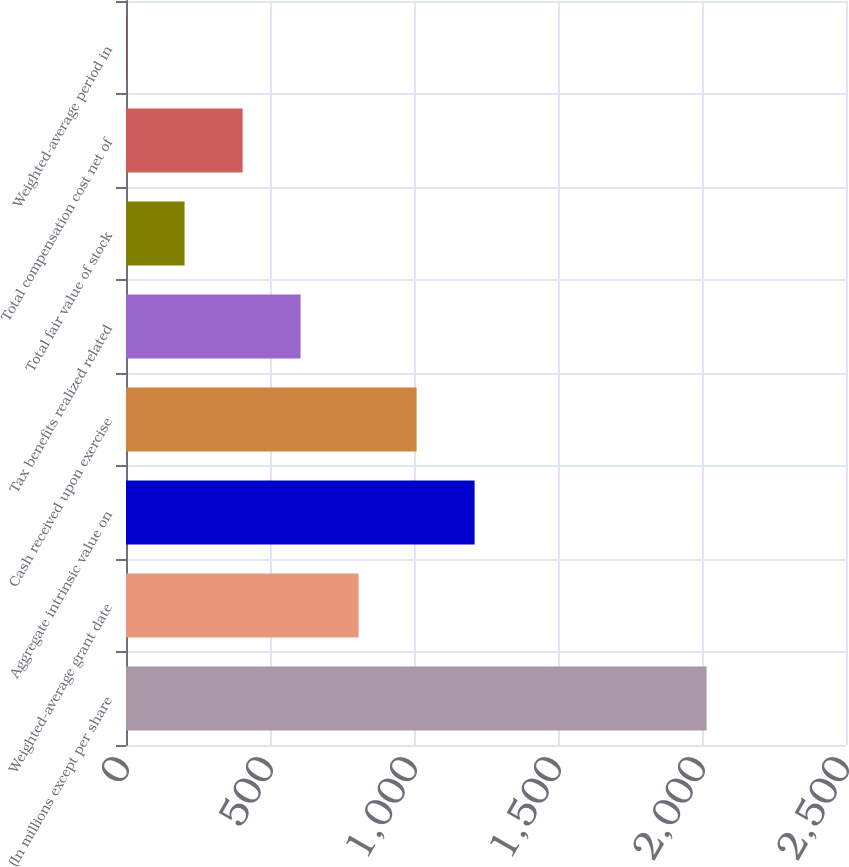Convert chart to OTSL. <chart><loc_0><loc_0><loc_500><loc_500><bar_chart><fcel>(In millions except per share<fcel>Weighted-average grant date<fcel>Aggregate intrinsic value on<fcel>Cash received upon exercise<fcel>Tax benefits realized related<fcel>Total fair value of stock<fcel>Total compensation cost net of<fcel>Weighted-average period in<nl><fcel>2016<fcel>807.6<fcel>1210.4<fcel>1009<fcel>606.2<fcel>203.4<fcel>404.8<fcel>2<nl></chart> 